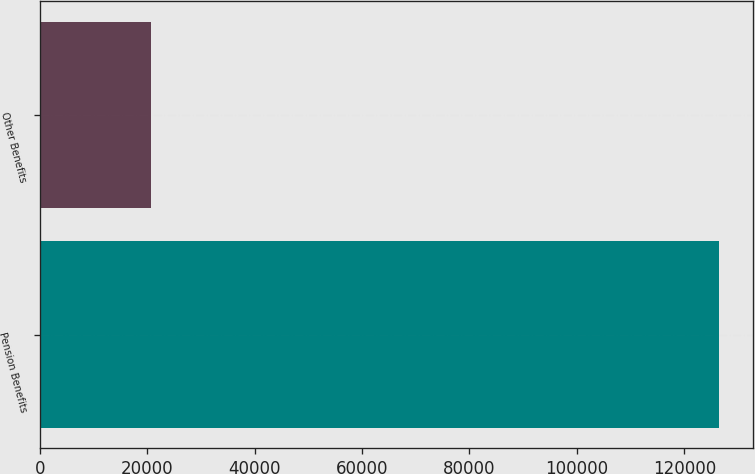Convert chart. <chart><loc_0><loc_0><loc_500><loc_500><bar_chart><fcel>Pension Benefits<fcel>Other Benefits<nl><fcel>126392<fcel>20773<nl></chart> 